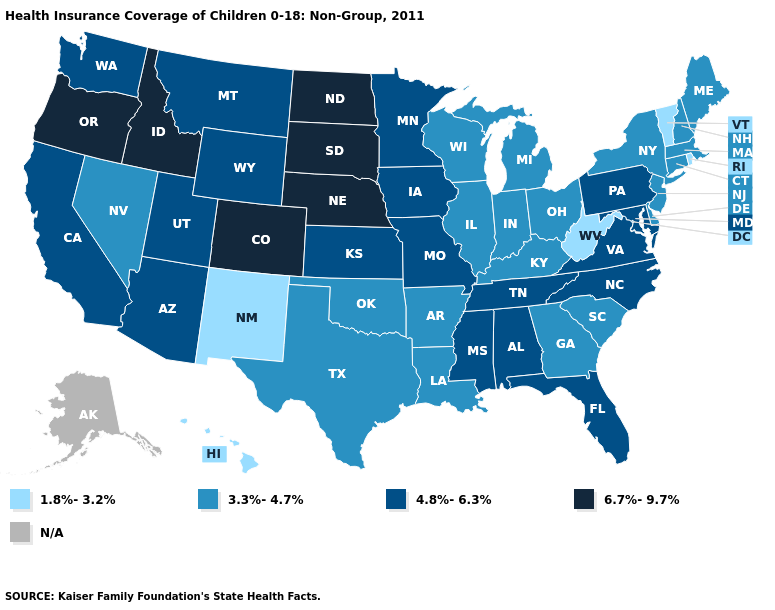What is the value of Ohio?
Give a very brief answer. 3.3%-4.7%. What is the lowest value in the USA?
Short answer required. 1.8%-3.2%. What is the highest value in the USA?
Answer briefly. 6.7%-9.7%. Does the first symbol in the legend represent the smallest category?
Short answer required. Yes. What is the highest value in states that border Arkansas?
Quick response, please. 4.8%-6.3%. Name the states that have a value in the range N/A?
Quick response, please. Alaska. Name the states that have a value in the range 4.8%-6.3%?
Concise answer only. Alabama, Arizona, California, Florida, Iowa, Kansas, Maryland, Minnesota, Mississippi, Missouri, Montana, North Carolina, Pennsylvania, Tennessee, Utah, Virginia, Washington, Wyoming. What is the highest value in the USA?
Short answer required. 6.7%-9.7%. Which states hav the highest value in the South?
Be succinct. Alabama, Florida, Maryland, Mississippi, North Carolina, Tennessee, Virginia. Name the states that have a value in the range 1.8%-3.2%?
Write a very short answer. Hawaii, New Mexico, Rhode Island, Vermont, West Virginia. How many symbols are there in the legend?
Concise answer only. 5. Among the states that border Minnesota , does South Dakota have the highest value?
Short answer required. Yes. Does North Carolina have the highest value in the South?
Keep it brief. Yes. 